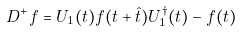<formula> <loc_0><loc_0><loc_500><loc_500>D ^ { + } f = U _ { 1 } ( t ) f ( t + \hat { t } ) U ^ { \dagger } _ { 1 } ( t ) - f ( t )</formula> 